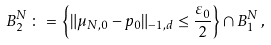Convert formula to latex. <formula><loc_0><loc_0><loc_500><loc_500>B ^ { N } _ { 2 } \, \colon = \, \left \{ \| \mu _ { N , 0 } - p _ { 0 } \| _ { - 1 , d } \leq \frac { \varepsilon _ { 0 } } { 2 } \right \} \cap B ^ { N } _ { 1 } \, ,</formula> 